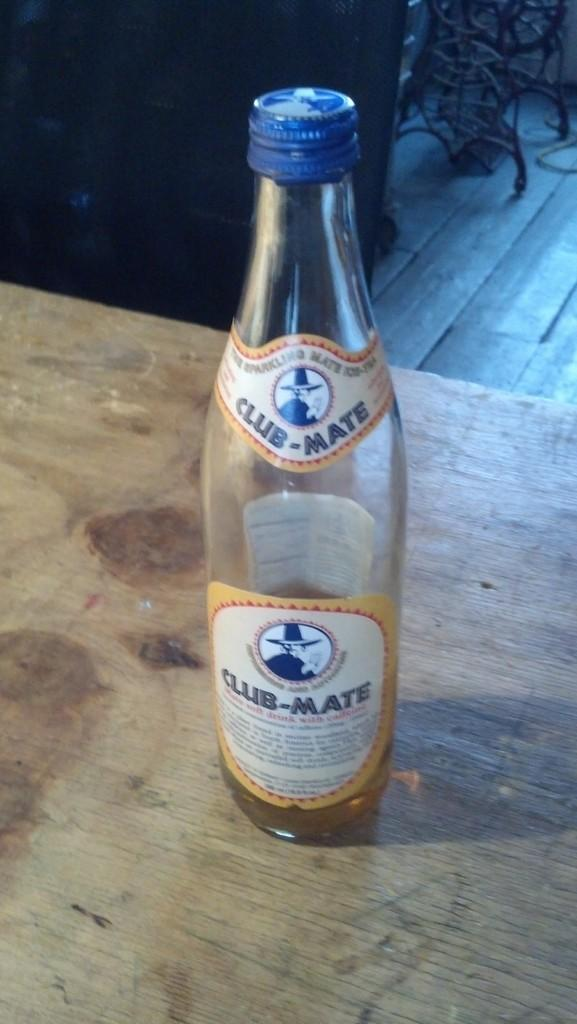<image>
Create a compact narrative representing the image presented. An empty bottle of Club-Mate has a blue cap on it. 